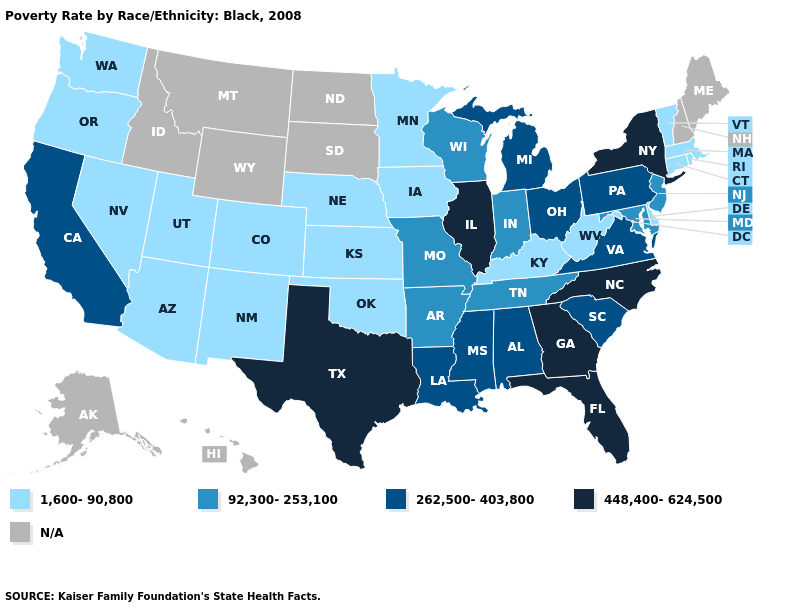Name the states that have a value in the range 1,600-90,800?
Short answer required. Arizona, Colorado, Connecticut, Delaware, Iowa, Kansas, Kentucky, Massachusetts, Minnesota, Nebraska, Nevada, New Mexico, Oklahoma, Oregon, Rhode Island, Utah, Vermont, Washington, West Virginia. What is the lowest value in the USA?
Write a very short answer. 1,600-90,800. What is the value of Maine?
Answer briefly. N/A. Name the states that have a value in the range N/A?
Concise answer only. Alaska, Hawaii, Idaho, Maine, Montana, New Hampshire, North Dakota, South Dakota, Wyoming. Name the states that have a value in the range 448,400-624,500?
Quick response, please. Florida, Georgia, Illinois, New York, North Carolina, Texas. Among the states that border Connecticut , which have the highest value?
Write a very short answer. New York. What is the highest value in the MidWest ?
Short answer required. 448,400-624,500. How many symbols are there in the legend?
Concise answer only. 5. Does Alabama have the highest value in the South?
Answer briefly. No. What is the highest value in states that border Wyoming?
Answer briefly. 1,600-90,800. What is the value of Oregon?
Write a very short answer. 1,600-90,800. Name the states that have a value in the range 262,500-403,800?
Quick response, please. Alabama, California, Louisiana, Michigan, Mississippi, Ohio, Pennsylvania, South Carolina, Virginia. Name the states that have a value in the range 1,600-90,800?
Answer briefly. Arizona, Colorado, Connecticut, Delaware, Iowa, Kansas, Kentucky, Massachusetts, Minnesota, Nebraska, Nevada, New Mexico, Oklahoma, Oregon, Rhode Island, Utah, Vermont, Washington, West Virginia. 